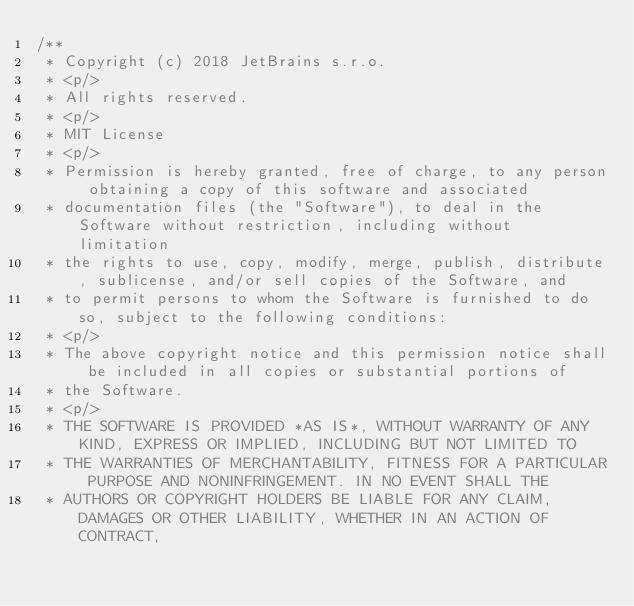<code> <loc_0><loc_0><loc_500><loc_500><_Kotlin_>/**
 * Copyright (c) 2018 JetBrains s.r.o.
 * <p/>
 * All rights reserved.
 * <p/>
 * MIT License
 * <p/>
 * Permission is hereby granted, free of charge, to any person obtaining a copy of this software and associated
 * documentation files (the "Software"), to deal in the Software without restriction, including without limitation
 * the rights to use, copy, modify, merge, publish, distribute, sublicense, and/or sell copies of the Software, and
 * to permit persons to whom the Software is furnished to do so, subject to the following conditions:
 * <p/>
 * The above copyright notice and this permission notice shall be included in all copies or substantial portions of
 * the Software.
 * <p/>
 * THE SOFTWARE IS PROVIDED *AS IS*, WITHOUT WARRANTY OF ANY KIND, EXPRESS OR IMPLIED, INCLUDING BUT NOT LIMITED TO
 * THE WARRANTIES OF MERCHANTABILITY, FITNESS FOR A PARTICULAR PURPOSE AND NONINFRINGEMENT. IN NO EVENT SHALL THE
 * AUTHORS OR COPYRIGHT HOLDERS BE LIABLE FOR ANY CLAIM, DAMAGES OR OTHER LIABILITY, WHETHER IN AN ACTION OF CONTRACT,</code> 